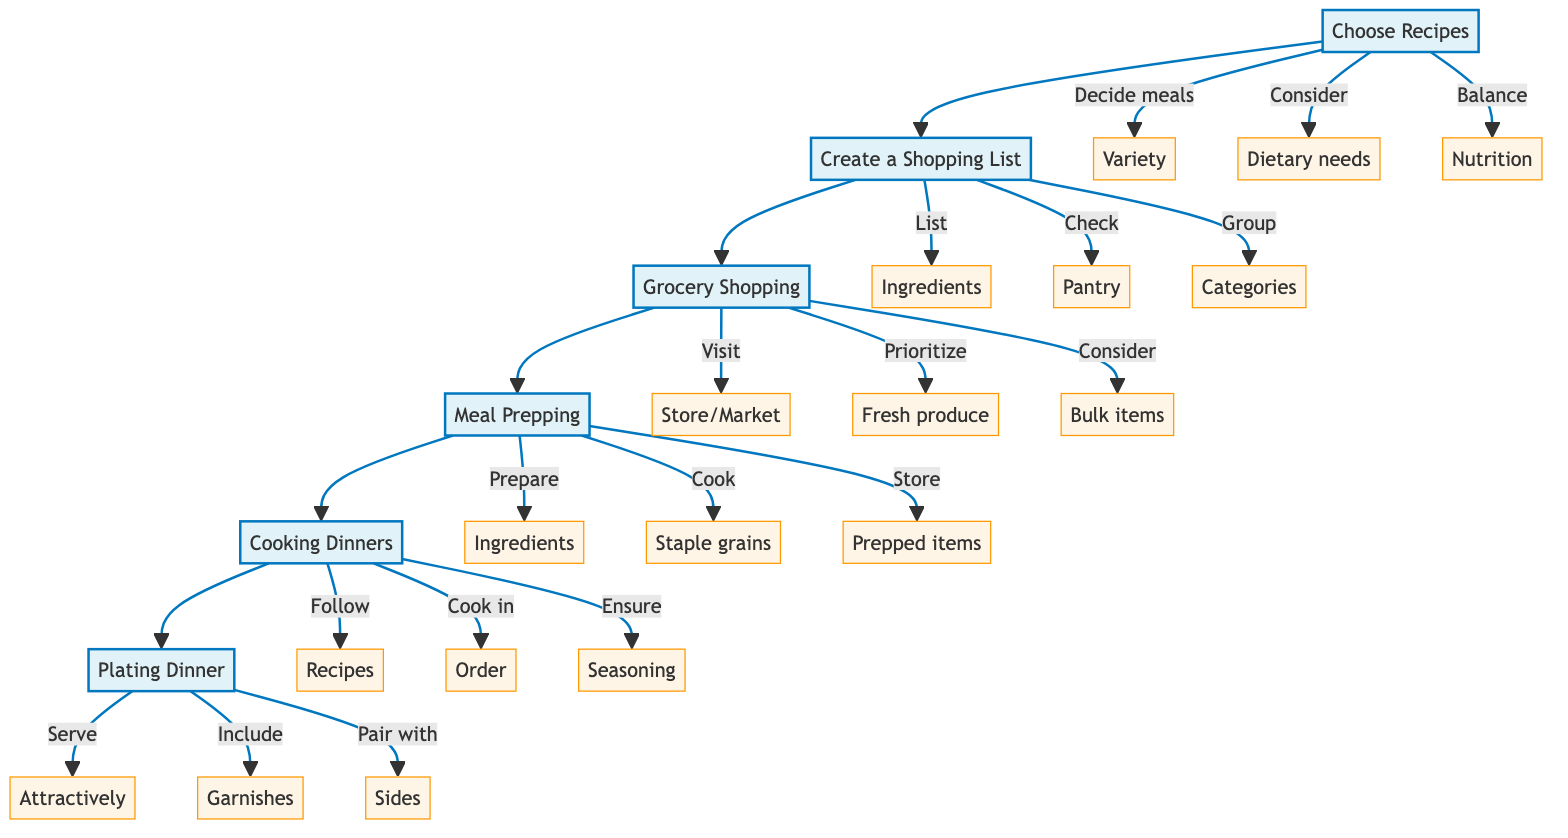How many main steps are in the meal planning process? The diagram outlines six main steps: Choose Recipes, Create a Shopping List, Grocery Shopping, Meal Prepping, Cooking Dinners, and Plating Dinner.
Answer: 6 What is the first step in the meal planning process? The first step listed in the diagram is "Choose Recipes".
Answer: Choose Recipes What is listed as the last action in the cooking phase? In the cooking phase, the last action before plating is ensuring proper seasoning and tasting, as shown in the details of the "Cooking Dinners" step.
Answer: Ensure proper seasoning and tasting Which step includes checking your pantry for existing items? The step that includes checking your pantry for existing items is "Create a Shopping List", as indicated in the details section.
Answer: Create a Shopping List What are the two considerations when choosing recipes? The two considerations when choosing recipes are dietary needs and preferences, and balancing nutritional components, as detailed in the "Choose Recipes" step.
Answer: Dietary needs and preferences, nutrition balance What type of items does the grocery shopping step prioritize? The "Grocery Shopping" step prioritizes fresh produce, as mentioned in the details of that step.
Answer: Fresh produce Which sub-step involves cooking staple grains? The sub-step that involves cooking staple grains is "Cook staple grains (rice, quinoa) in batches", which is part of the "Meal Prepping" step.
Answer: Cook staple grains What is the purpose of grouping items by category in the shopping list? Grouping items by category in the shopping list helps to organize ingredients effectively to make shopping easier, as explained in the "Create a Shopping List" step.
Answer: Organize ingredients effectively What should be included for plating to enhance visual appeal? The diagram suggests including garnishes for added flavor and visual appeal when plating dinner, as indicated in the "Plating Dinner" step.
Answer: Garnishes 